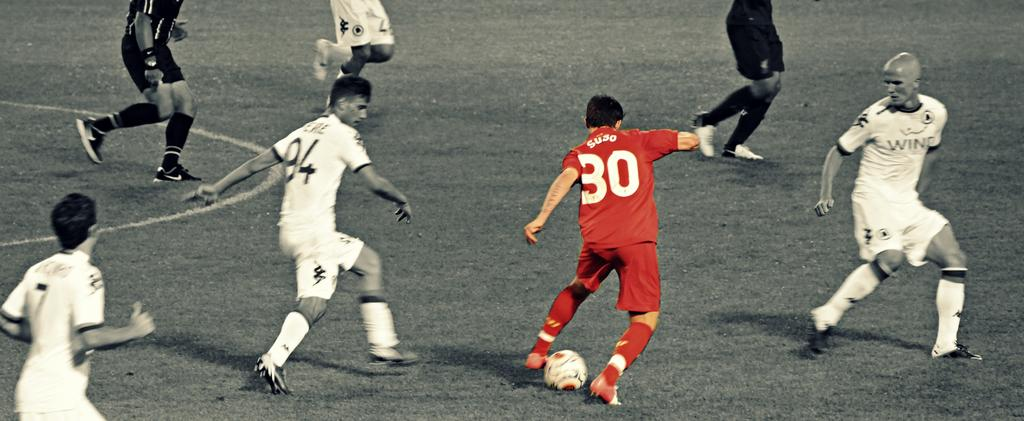<image>
Write a terse but informative summary of the picture. Soccer player number 94 trying to steal the ball from Suso number 30. 